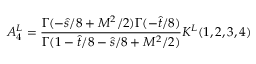<formula> <loc_0><loc_0><loc_500><loc_500>A _ { 4 } ^ { L } = { \frac { \Gamma ( - \hat { s } / 8 + M ^ { 2 } / 2 ) \Gamma ( - \hat { t } / 8 ) } { \Gamma ( 1 - \hat { t } / 8 - \hat { s } / 8 + M ^ { 2 } / 2 ) } } K ^ { L } ( 1 , 2 , 3 , 4 )</formula> 